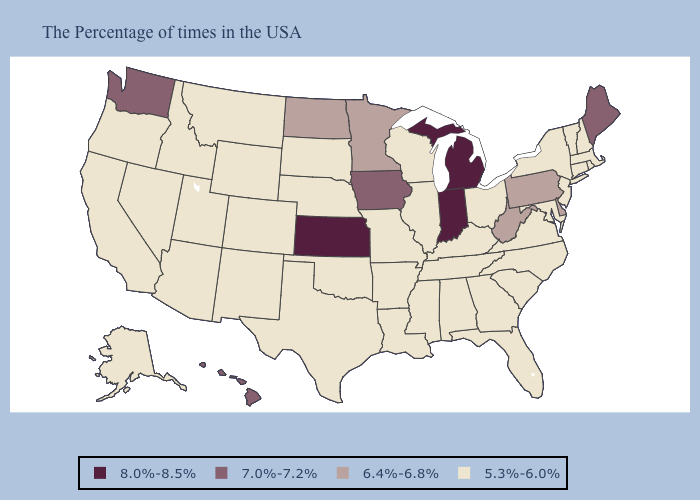Name the states that have a value in the range 5.3%-6.0%?
Write a very short answer. Massachusetts, Rhode Island, New Hampshire, Vermont, Connecticut, New York, New Jersey, Maryland, Virginia, North Carolina, South Carolina, Ohio, Florida, Georgia, Kentucky, Alabama, Tennessee, Wisconsin, Illinois, Mississippi, Louisiana, Missouri, Arkansas, Nebraska, Oklahoma, Texas, South Dakota, Wyoming, Colorado, New Mexico, Utah, Montana, Arizona, Idaho, Nevada, California, Oregon, Alaska. What is the value of Michigan?
Give a very brief answer. 8.0%-8.5%. What is the value of Florida?
Short answer required. 5.3%-6.0%. Does Delaware have the same value as West Virginia?
Answer briefly. Yes. Among the states that border Mississippi , which have the highest value?
Short answer required. Alabama, Tennessee, Louisiana, Arkansas. Does the map have missing data?
Concise answer only. No. What is the lowest value in the USA?
Quick response, please. 5.3%-6.0%. Does the first symbol in the legend represent the smallest category?
Write a very short answer. No. What is the value of Vermont?
Concise answer only. 5.3%-6.0%. What is the value of Washington?
Concise answer only. 7.0%-7.2%. Name the states that have a value in the range 7.0%-7.2%?
Concise answer only. Maine, Iowa, Washington, Hawaii. What is the lowest value in the USA?
Answer briefly. 5.3%-6.0%. Does West Virginia have the lowest value in the South?
Write a very short answer. No. Does the map have missing data?
Quick response, please. No. 